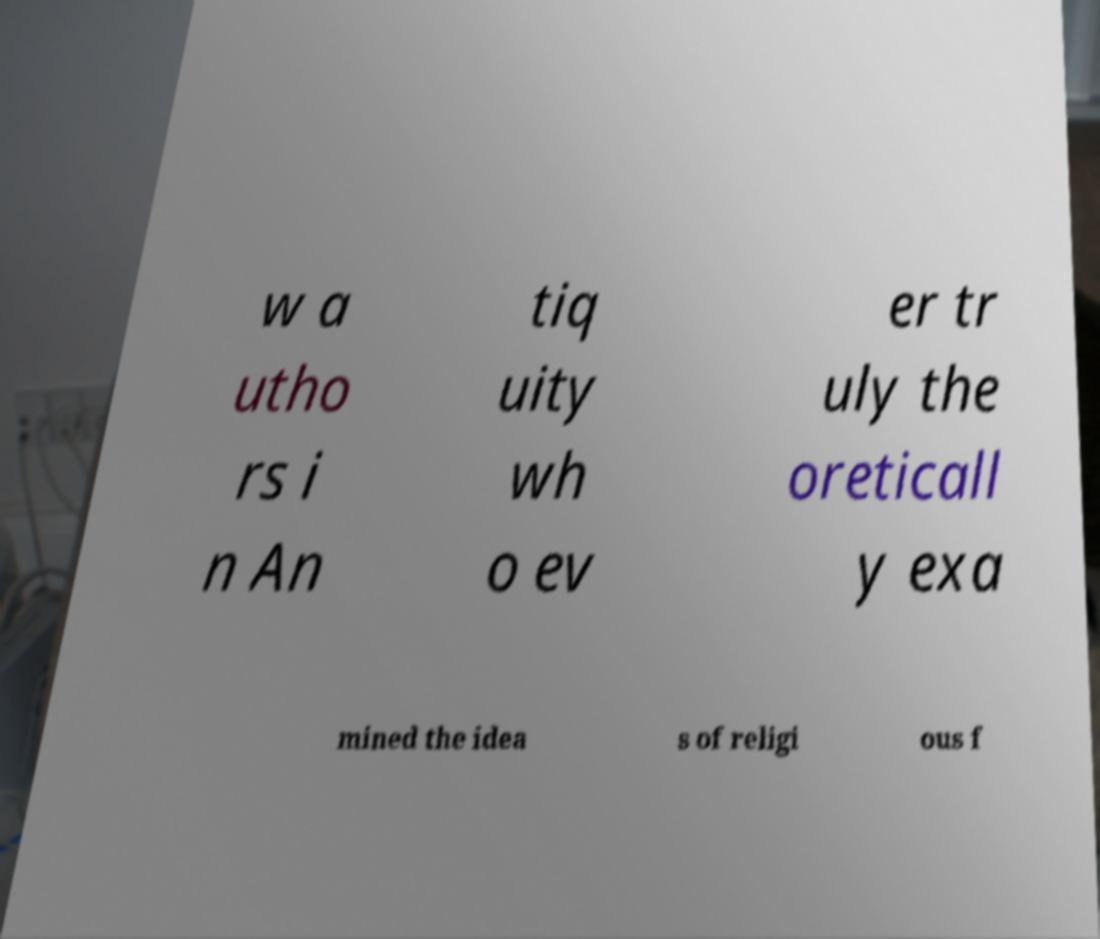Please read and relay the text visible in this image. What does it say? w a utho rs i n An tiq uity wh o ev er tr uly the oreticall y exa mined the idea s of religi ous f 